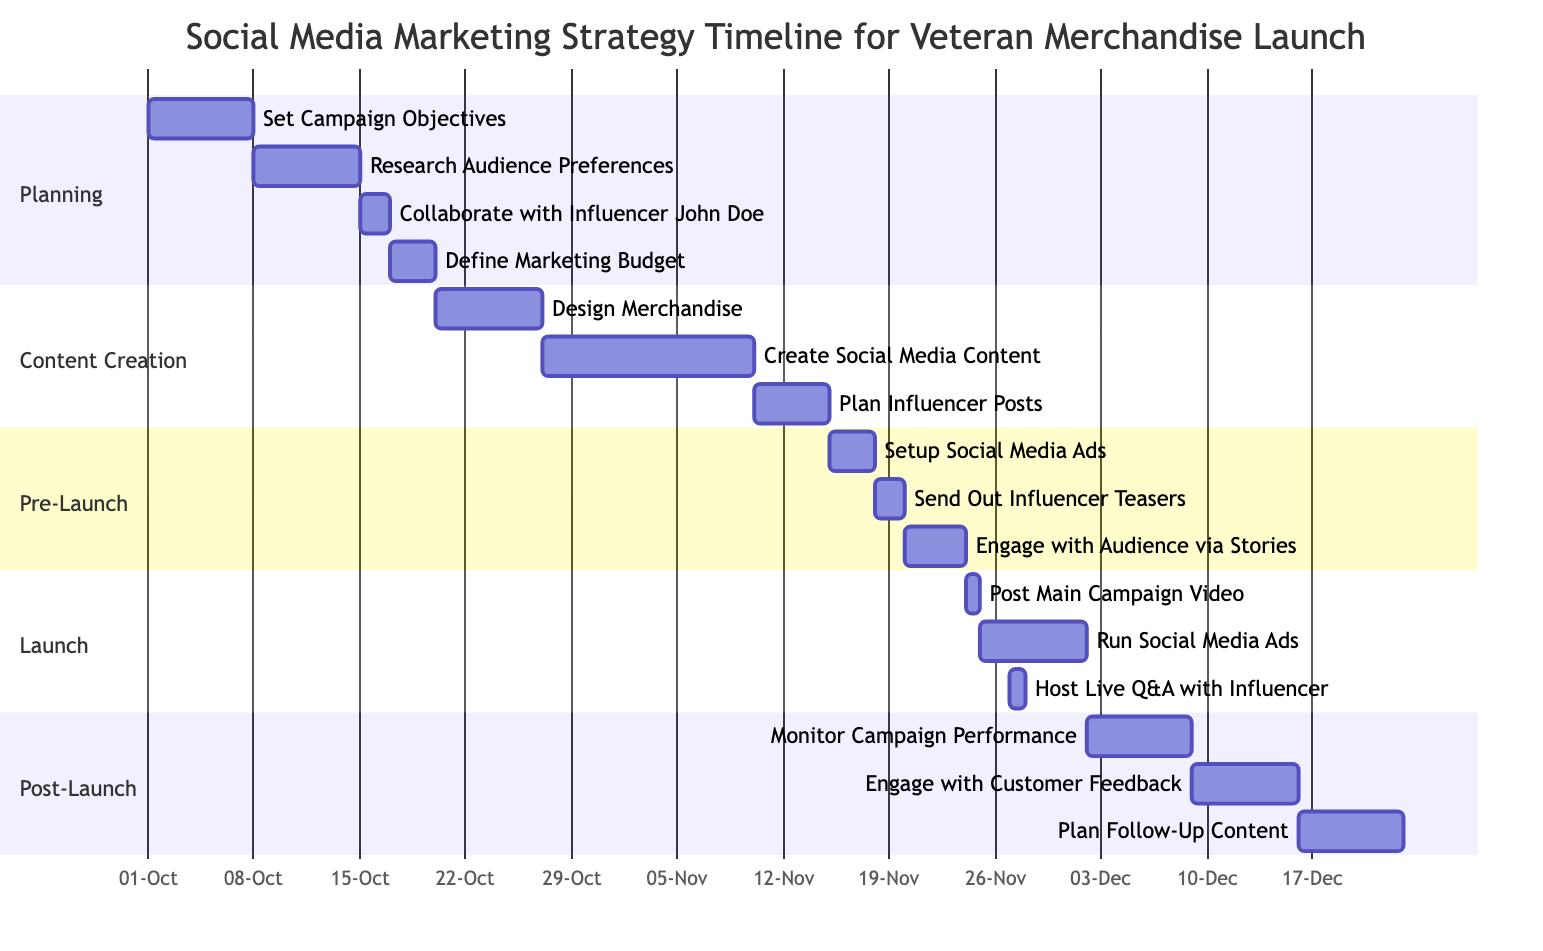What is the duration of the "Set Campaign Objectives" task? The task "Set Campaign Objectives" is indicated to take 1 week, which is specified directly next to the task in the diagram’s timeline.
Answer: 1 week What is the end date for "Engage with Audience via Stories"? The "Engage with Audience via Stories" task ends on November 23, 2023, as shown by its positioning on the timeline.
Answer: November 23, 2023 How many tasks are there in the "Content Creation" phase? In the "Content Creation" phase, there are three tasks listed: "Design Merchandise", "Create Social Media Content", and "Plan Influencer Posts." Counting these gives a total of three tasks.
Answer: 3 Which task follows "Collaborate with Influencer John Doe"? The task that follows "Collaborate with Influencer John Doe" is "Define Marketing Budget", as it is shown to start immediately after the completion of the prior task.
Answer: Define Marketing Budget What task overlaps with "Run Social Media Ads"? The task "Host Live Q&A with Influencer" overlaps with "Run Social Media Ads" as they both extend into the same period of time on the timeline.
Answer: Host Live Q&A with Influencer When does the "Monitor Campaign Performance" task start? The "Monitor Campaign Performance" task starts on December 2, 2023, as indicated by its starting date on the Gantt chart.
Answer: December 2, 2023 What is the total duration of the "Launch" phase? The "Launch" phase contains three tasks: "Post Main Campaign Video" for 1 day, "Run Social Media Ads" for 1 week, and "Host Live Q&A with Influencer" for 1 day. Adding the durations gives a total of 8 days (1 day + 7 days + 1 day).
Answer: 8 days Which task is the first in the "Pre-Launch" phase? The first task listed in the "Pre-Launch" phase is "Setup Social Media Ads," which is the initial task displayed within that section on the diagram.
Answer: Setup Social Media Ads How long does "Create Social Media Content" take? The task "Create Social Media Content" is scheduled for 2 weeks according to the timeline, as indicated beside the task in the diagram.
Answer: 2 weeks 